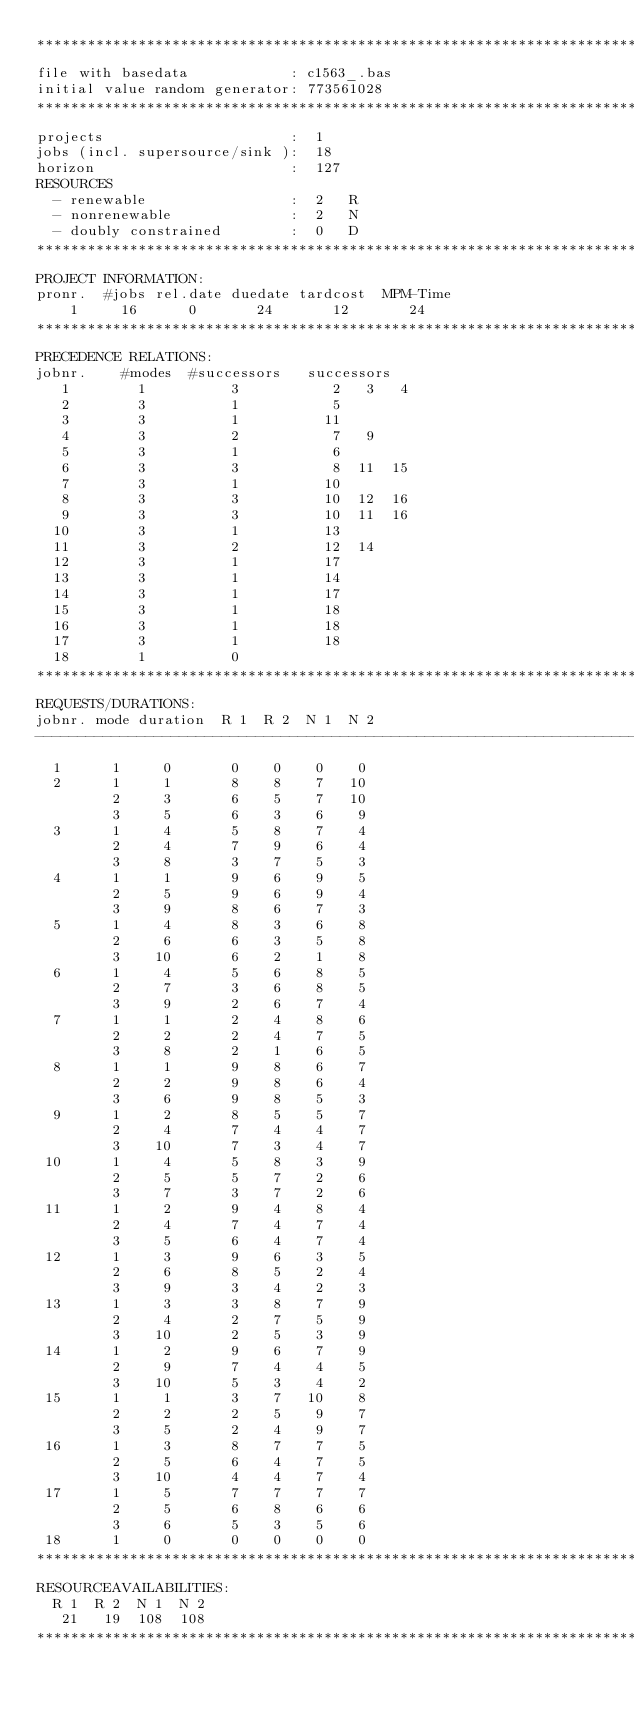Convert code to text. <code><loc_0><loc_0><loc_500><loc_500><_ObjectiveC_>************************************************************************
file with basedata            : c1563_.bas
initial value random generator: 773561028
************************************************************************
projects                      :  1
jobs (incl. supersource/sink ):  18
horizon                       :  127
RESOURCES
  - renewable                 :  2   R
  - nonrenewable              :  2   N
  - doubly constrained        :  0   D
************************************************************************
PROJECT INFORMATION:
pronr.  #jobs rel.date duedate tardcost  MPM-Time
    1     16      0       24       12       24
************************************************************************
PRECEDENCE RELATIONS:
jobnr.    #modes  #successors   successors
   1        1          3           2   3   4
   2        3          1           5
   3        3          1          11
   4        3          2           7   9
   5        3          1           6
   6        3          3           8  11  15
   7        3          1          10
   8        3          3          10  12  16
   9        3          3          10  11  16
  10        3          1          13
  11        3          2          12  14
  12        3          1          17
  13        3          1          14
  14        3          1          17
  15        3          1          18
  16        3          1          18
  17        3          1          18
  18        1          0        
************************************************************************
REQUESTS/DURATIONS:
jobnr. mode duration  R 1  R 2  N 1  N 2
------------------------------------------------------------------------
  1      1     0       0    0    0    0
  2      1     1       8    8    7   10
         2     3       6    5    7   10
         3     5       6    3    6    9
  3      1     4       5    8    7    4
         2     4       7    9    6    4
         3     8       3    7    5    3
  4      1     1       9    6    9    5
         2     5       9    6    9    4
         3     9       8    6    7    3
  5      1     4       8    3    6    8
         2     6       6    3    5    8
         3    10       6    2    1    8
  6      1     4       5    6    8    5
         2     7       3    6    8    5
         3     9       2    6    7    4
  7      1     1       2    4    8    6
         2     2       2    4    7    5
         3     8       2    1    6    5
  8      1     1       9    8    6    7
         2     2       9    8    6    4
         3     6       9    8    5    3
  9      1     2       8    5    5    7
         2     4       7    4    4    7
         3    10       7    3    4    7
 10      1     4       5    8    3    9
         2     5       5    7    2    6
         3     7       3    7    2    6
 11      1     2       9    4    8    4
         2     4       7    4    7    4
         3     5       6    4    7    4
 12      1     3       9    6    3    5
         2     6       8    5    2    4
         3     9       3    4    2    3
 13      1     3       3    8    7    9
         2     4       2    7    5    9
         3    10       2    5    3    9
 14      1     2       9    6    7    9
         2     9       7    4    4    5
         3    10       5    3    4    2
 15      1     1       3    7   10    8
         2     2       2    5    9    7
         3     5       2    4    9    7
 16      1     3       8    7    7    5
         2     5       6    4    7    5
         3    10       4    4    7    4
 17      1     5       7    7    7    7
         2     5       6    8    6    6
         3     6       5    3    5    6
 18      1     0       0    0    0    0
************************************************************************
RESOURCEAVAILABILITIES:
  R 1  R 2  N 1  N 2
   21   19  108  108
************************************************************************
</code> 